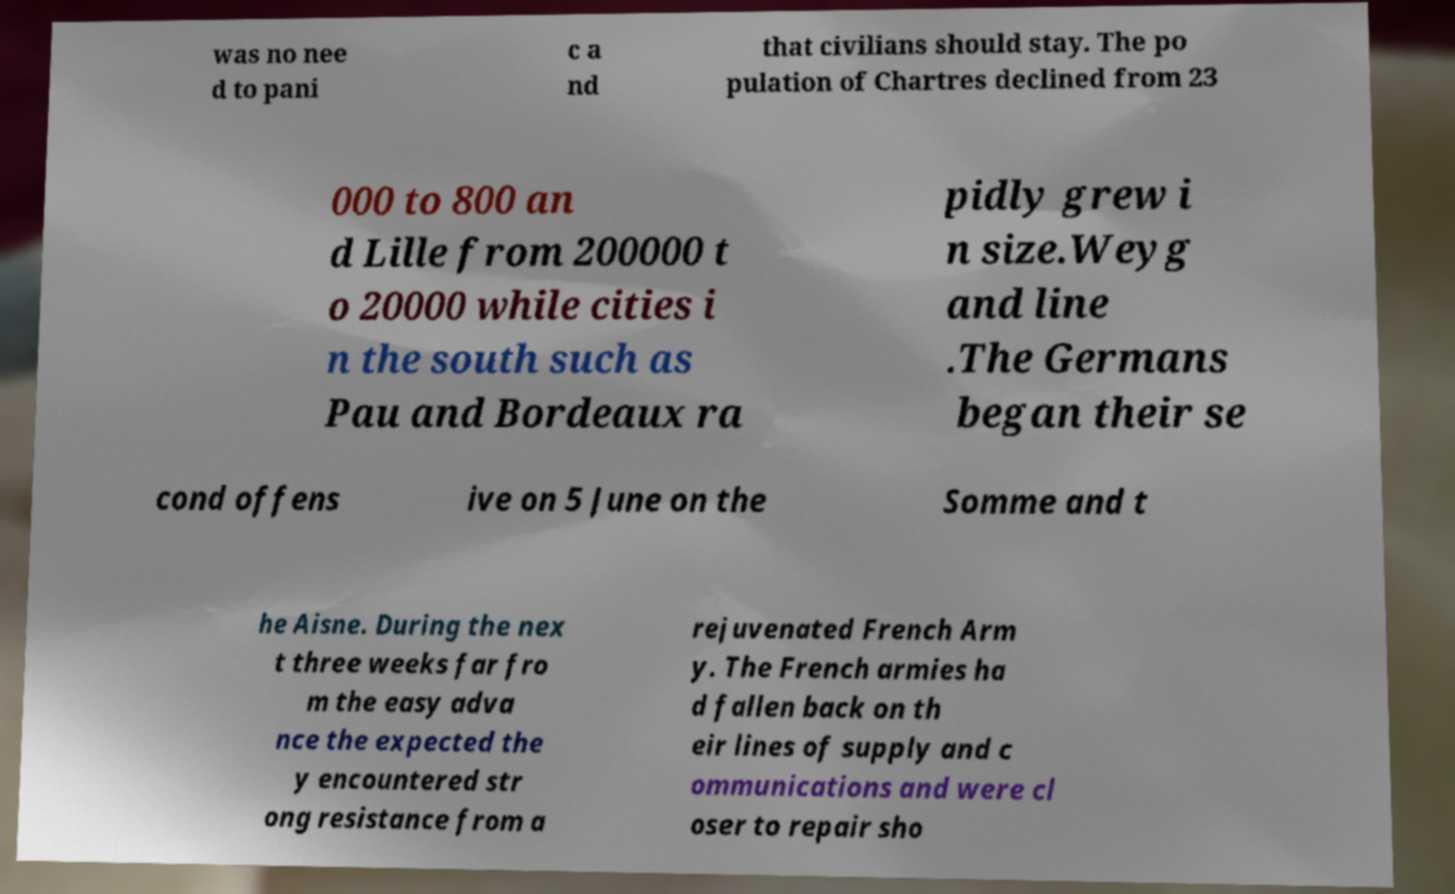Could you assist in decoding the text presented in this image and type it out clearly? was no nee d to pani c a nd that civilians should stay. The po pulation of Chartres declined from 23 000 to 800 an d Lille from 200000 t o 20000 while cities i n the south such as Pau and Bordeaux ra pidly grew i n size.Weyg and line .The Germans began their se cond offens ive on 5 June on the Somme and t he Aisne. During the nex t three weeks far fro m the easy adva nce the expected the y encountered str ong resistance from a rejuvenated French Arm y. The French armies ha d fallen back on th eir lines of supply and c ommunications and were cl oser to repair sho 